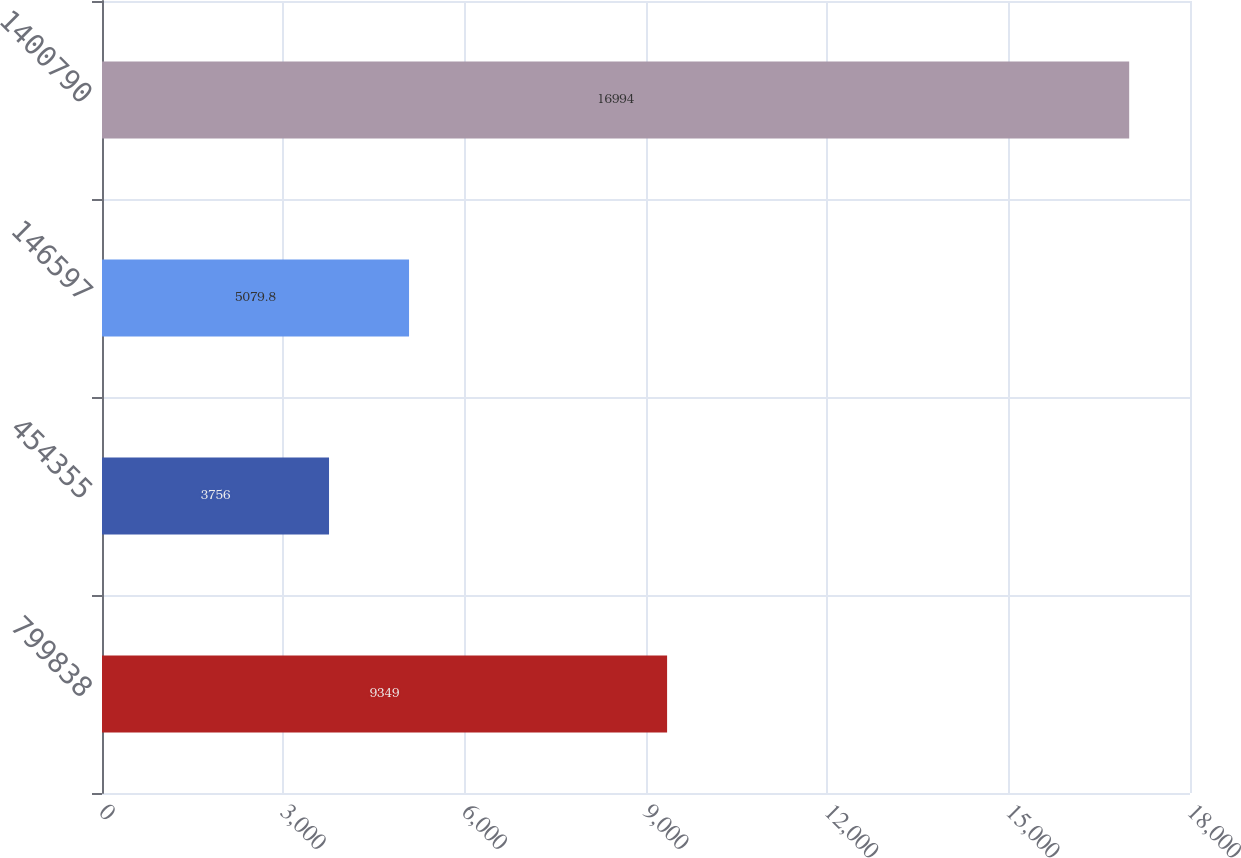Convert chart. <chart><loc_0><loc_0><loc_500><loc_500><bar_chart><fcel>799838<fcel>454355<fcel>146597<fcel>1400790<nl><fcel>9349<fcel>3756<fcel>5079.8<fcel>16994<nl></chart> 